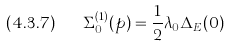Convert formula to latex. <formula><loc_0><loc_0><loc_500><loc_500>( 4 . 3 . 7 ) \quad \Sigma _ { 0 } ^ { ( 1 ) } ( p ) = \frac { 1 } { 2 } \lambda _ { 0 } \Delta _ { E } ( 0 )</formula> 